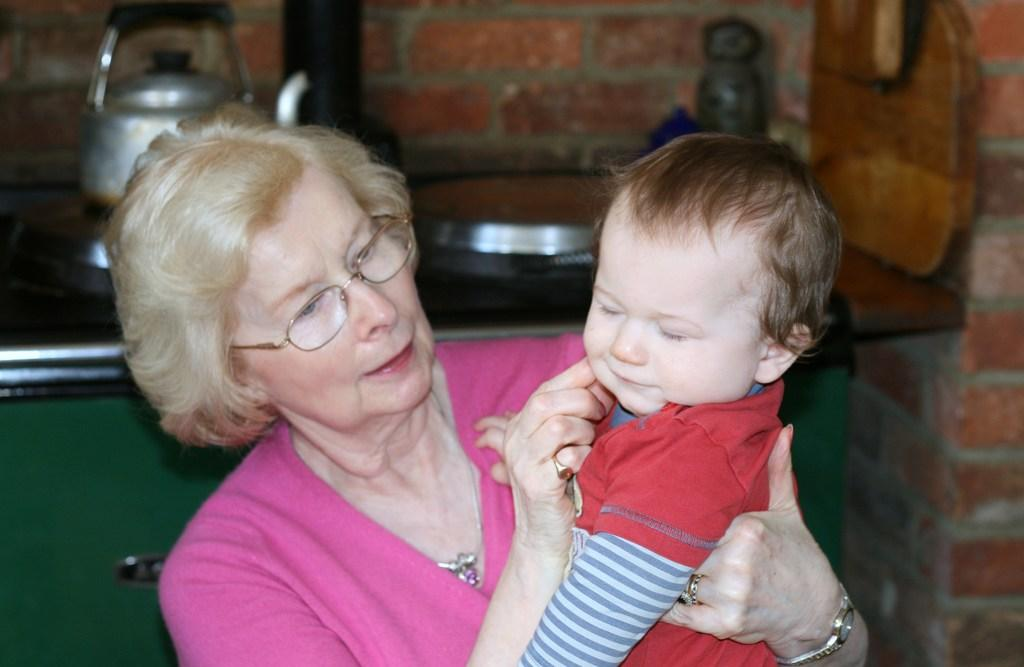What is the lady doing in the image? The lady is carrying a kid in the image. What objects can be seen on the kitchen slab? There is a teapot, a plate, and a bottle on the kitchen slab. What type of wall is visible in the image? There is a brick wall in the image. What material is the board in the image made of? The board in the image is made of wood. What type of furniture is present in the image? There is a closet in the image. What type of trade does the fireman in the image specialize in? There is no fireman present in the image. What direction is the lady walking in the image? The lady is not walking in the image; she is carrying a kid. 